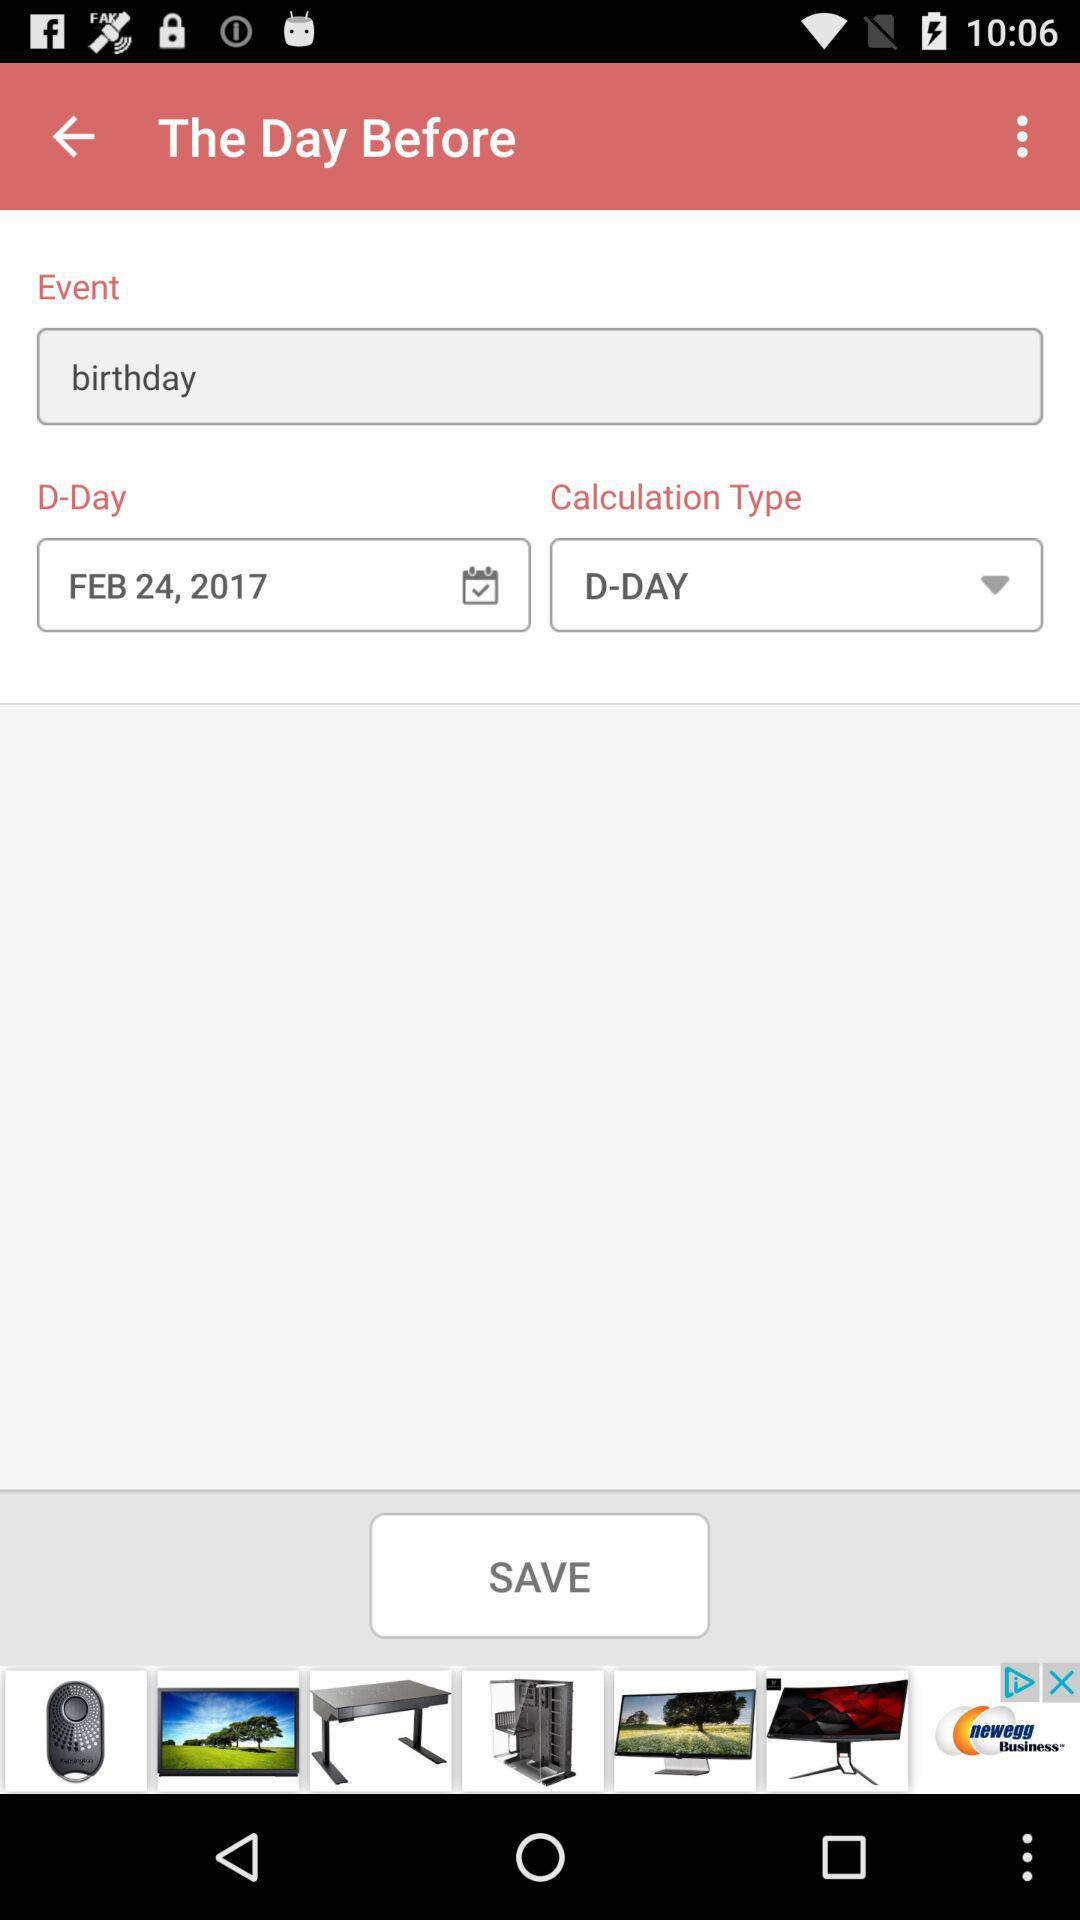What is the event? The event is "birthday". 